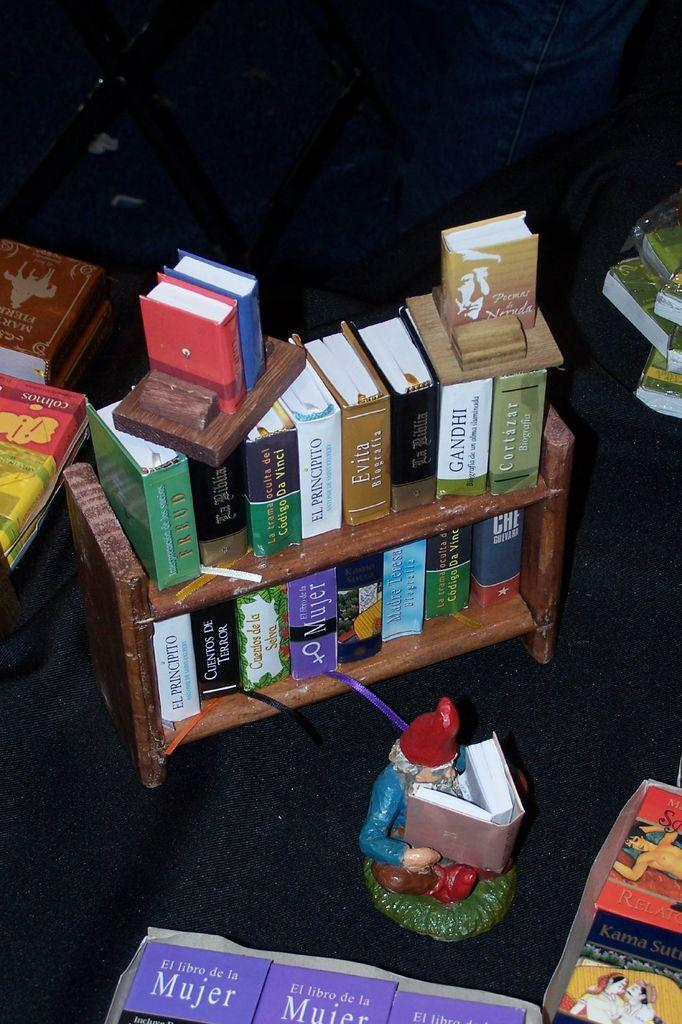Provide a one-sentence caption for the provided image. A collection of books includes several copies of El Libro De La Mujer with a purple cover. 